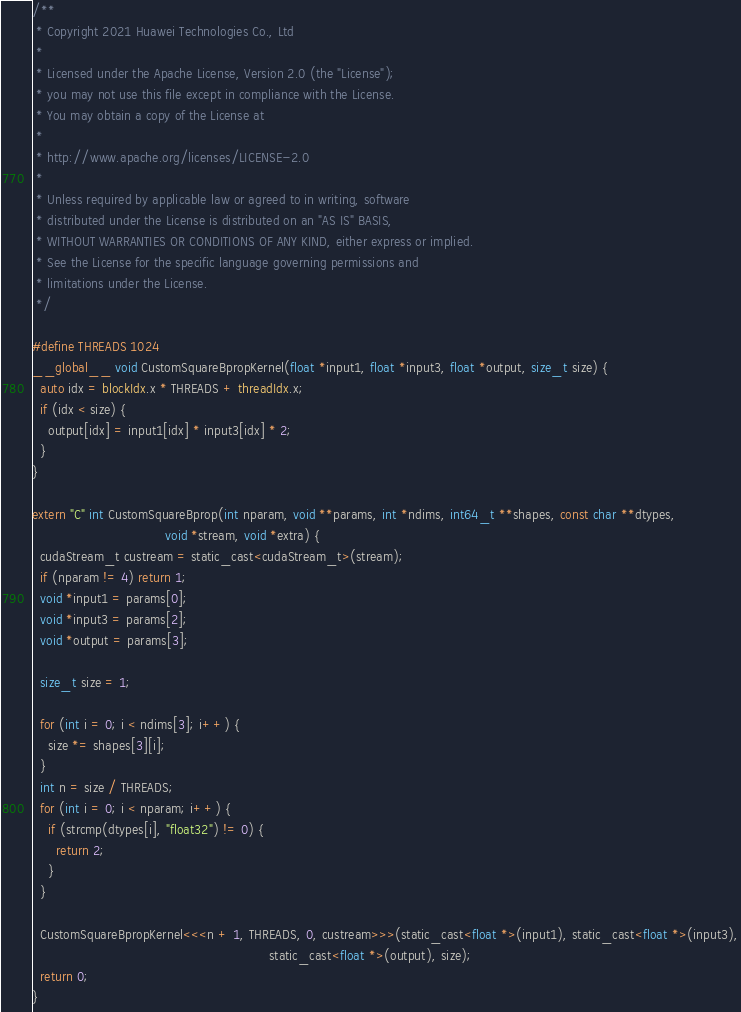Convert code to text. <code><loc_0><loc_0><loc_500><loc_500><_Cuda_>/**
 * Copyright 2021 Huawei Technologies Co., Ltd
 *
 * Licensed under the Apache License, Version 2.0 (the "License");
 * you may not use this file except in compliance with the License.
 * You may obtain a copy of the License at
 *
 * http://www.apache.org/licenses/LICENSE-2.0
 *
 * Unless required by applicable law or agreed to in writing, software
 * distributed under the License is distributed on an "AS IS" BASIS,
 * WITHOUT WARRANTIES OR CONDITIONS OF ANY KIND, either express or implied.
 * See the License for the specific language governing permissions and
 * limitations under the License.
 */

#define THREADS 1024
__global__ void CustomSquareBpropKernel(float *input1, float *input3, float *output, size_t size) {
  auto idx = blockIdx.x * THREADS + threadIdx.x;
  if (idx < size) {
    output[idx] = input1[idx] * input3[idx] * 2;
  }
}

extern "C" int CustomSquareBprop(int nparam, void **params, int *ndims, int64_t **shapes, const char **dtypes,
                                 void *stream, void *extra) {
  cudaStream_t custream = static_cast<cudaStream_t>(stream);
  if (nparam != 4) return 1;
  void *input1 = params[0];
  void *input3 = params[2];
  void *output = params[3];

  size_t size = 1;

  for (int i = 0; i < ndims[3]; i++) {
    size *= shapes[3][i];
  }
  int n = size / THREADS;
  for (int i = 0; i < nparam; i++) {
    if (strcmp(dtypes[i], "float32") != 0) {
      return 2;
    }
  }

  CustomSquareBpropKernel<<<n + 1, THREADS, 0, custream>>>(static_cast<float *>(input1), static_cast<float *>(input3),
                                                           static_cast<float *>(output), size);
  return 0;
}
</code> 